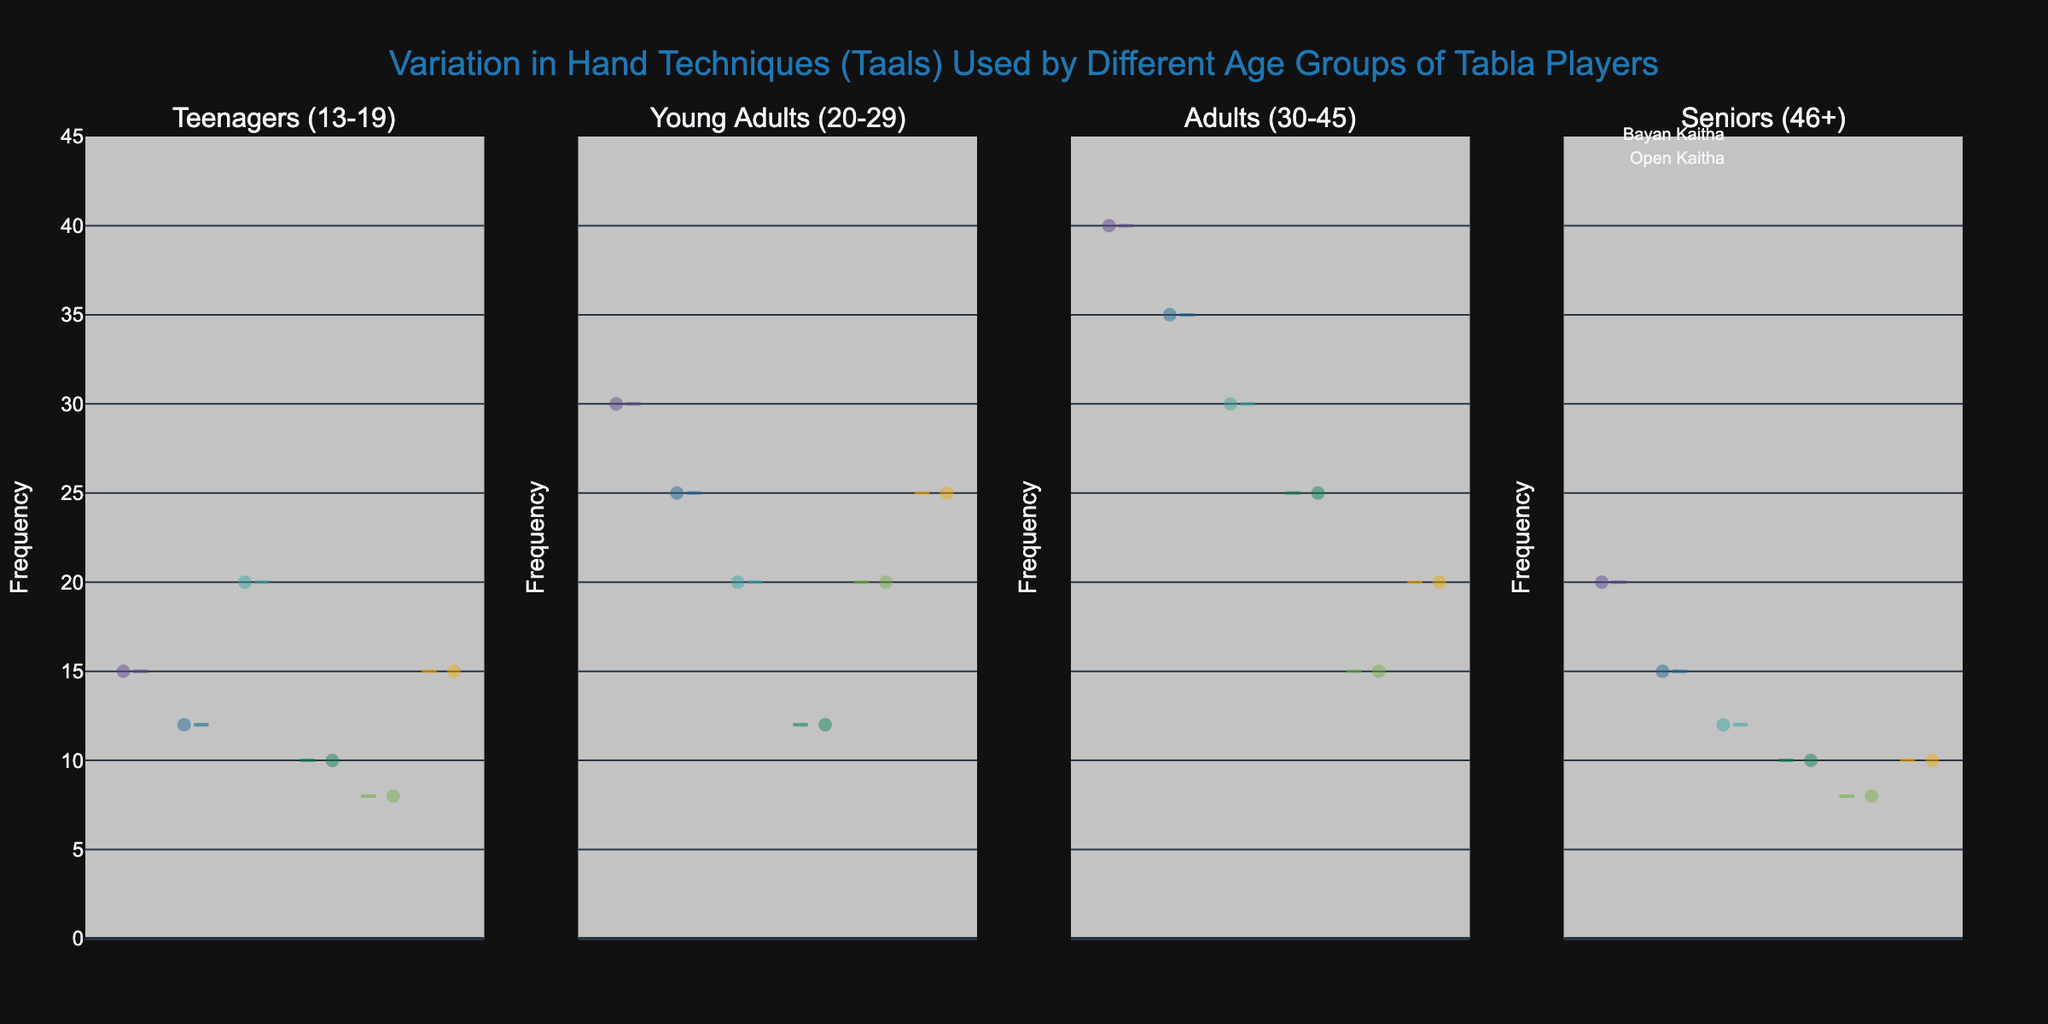What's the title of the plot? The title of the plot is located at the top of the figure, displayed clearly for easy identification.
Answer: Variation in Hand Techniques (Taals) Used by Different Age Groups of Tabla Players Which age group shows the highest frequency for 'Daya Tali'? By observing the plot for each age group and comparing the height of the violin plots for 'Daya Tali', the age group with the highest frequency can be determined.
Answer: Adults (30-45) How does the frequency of 'Open Kaitha' compare between Teenagers and Young Adults? To determine this, compare the plot heights for 'Open Kaitha' under Teenagers and Young Adults.
Answer: Young Adults use 'Open Kaitha' more frequently than Teenagers Which hand technique has the least frequency among Seniors (46+)? By examining the violin plots for Seniors, the hand technique with the lowest plot height is identified as the least frequent.
Answer: Bayan Kaitha Compare the usage of 'Bayan Tali' across the four age groups. This requires looking at all four subplots and identifying the frequencies for 'Bayan Tali' in each. Teenagers (12), Young Adults (25), Adults (35), Seniors (15). Hence, the order from most to least is Adults > Young Adults > Seniors > Teenagers.
Answer: Adults > Young Adults > Seniors > Teenagers What is the mean frequency of 'Daya Kaitha' across all age groups? Calculate the sum of the frequencies of 'Daya Kaitha' for each age group and then divide by the number of age groups. (10 + 12 + 25 + 10) / 4 = 57 / 4 = 14.25
Answer: 14.25 Which hand technique shows the most variation in frequency within the Adults age group? Variation in a violin plot can be identified by the spread of the data points. Find the technique where the plot varies the most within the Adults.
Answer: Daya Tali How does the frequency of 'Bayan Tali' in Young Adults compare to 'Bayan Kaitha' in Young Adults? Compare the heights of the violin plots for 'Bayan Tali' and 'Bayan Kaitha' within the Young Adults age group.
Answer: Bayan Tali is more frequent than Bayan Kaitha in Young Adults What insights can be drawn about the hand technique 'Daya Tali' across different age groups? Examine the 'Daya Tali' plots across all four age groups: Teenagers (15), Young Adults (30), Adults (40), and Seniors (20). Notice the different heights and summarize the pattern.
Answer: The frequency increases from Teenagers to Adults, then decreases for Seniors 